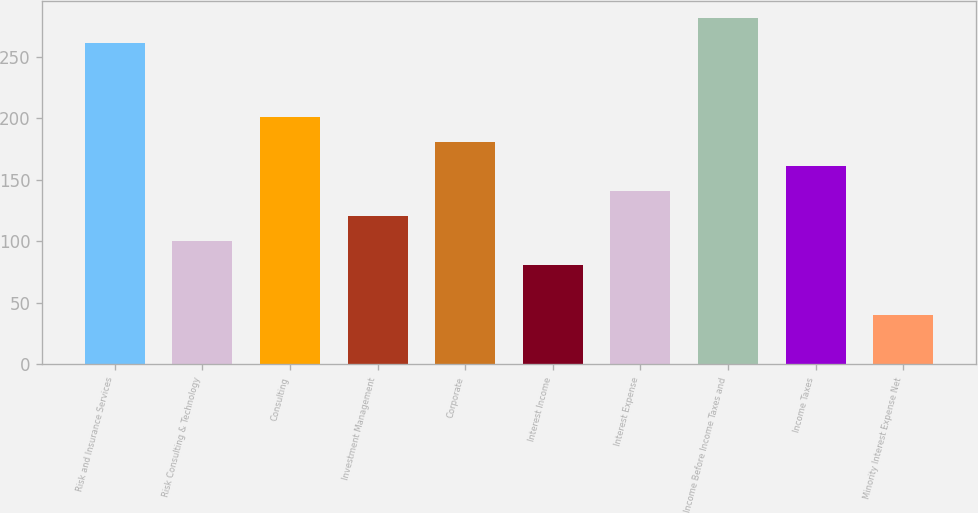Convert chart to OTSL. <chart><loc_0><loc_0><loc_500><loc_500><bar_chart><fcel>Risk and Insurance Services<fcel>Risk Consulting & Technology<fcel>Consulting<fcel>Investment Management<fcel>Corporate<fcel>Interest Income<fcel>Interest Expense<fcel>Income Before Income Taxes and<fcel>Income Taxes<fcel>Minority Interest Expense Net<nl><fcel>261.28<fcel>100.64<fcel>201.04<fcel>120.72<fcel>180.96<fcel>80.56<fcel>140.8<fcel>281.36<fcel>160.88<fcel>40.4<nl></chart> 